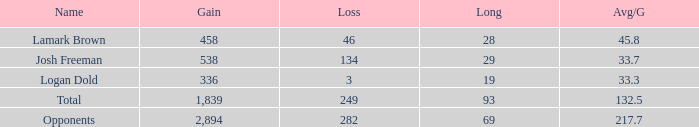Which avg/g is associated with josh freeman and has a loss under 134? None. 